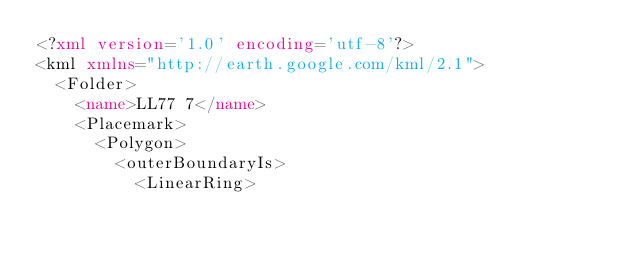Convert code to text. <code><loc_0><loc_0><loc_500><loc_500><_XML_><?xml version='1.0' encoding='utf-8'?>
<kml xmlns="http://earth.google.com/kml/2.1">
  <Folder>
    <name>LL77 7</name>
    <Placemark>
      <Polygon>
        <outerBoundaryIs>
          <LinearRing></code> 